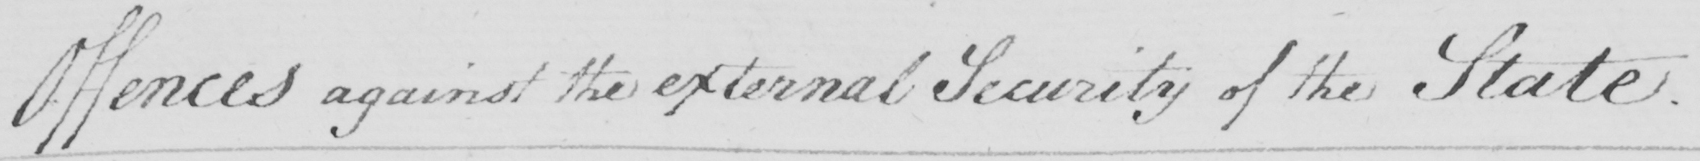What is written in this line of handwriting? Offences against the external Security of the State. 